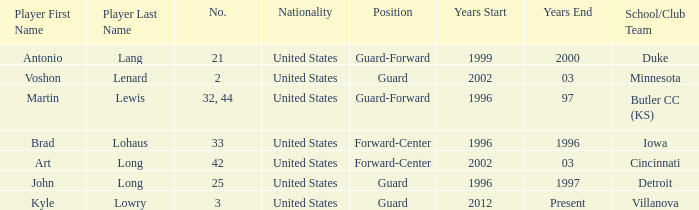How many schools did player number 3 play at? 1.0. 